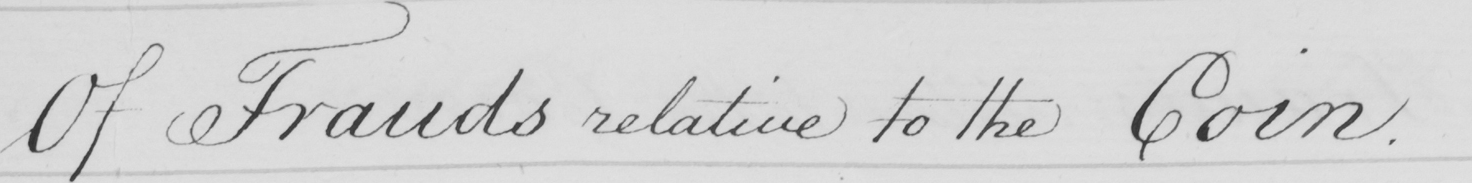What text is written in this handwritten line? Of frauds relative to the Coin . 